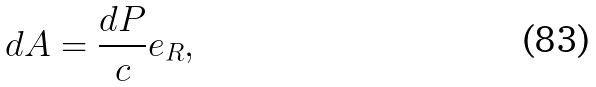<formula> <loc_0><loc_0><loc_500><loc_500>d A = \frac { d P } { c } e _ { R } ,</formula> 